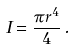Convert formula to latex. <formula><loc_0><loc_0><loc_500><loc_500>I = \frac { \pi r ^ { 4 } } { 4 } \, .</formula> 